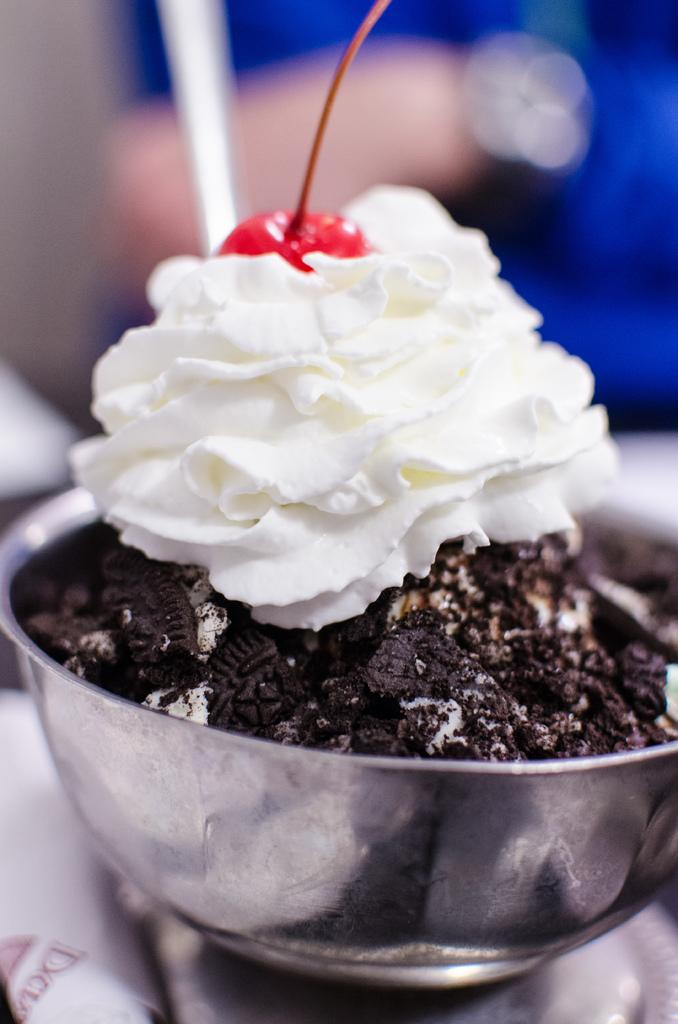What type of bowl is in the image? There is a steel bowl in the image. What is inside the bowl? There is cream in the bowl. Is there any fruit on the cream? Yes, there is a strawberry on the cream. Can you describe the background of the image? The background of the image appears blurry. Is there a gun on the table next to the bowl in the image? There is no gun present in the image. What type of paper is being used to cover the strawberry in the image? There is no paper covering the strawberry in the image; it is directly on the cream. 